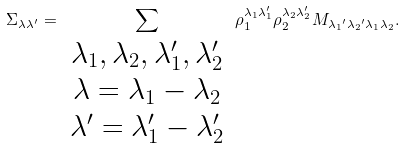<formula> <loc_0><loc_0><loc_500><loc_500>\Sigma _ { \lambda \lambda ^ { \prime } } = \sum _ { \begin{array} { c } \lambda _ { 1 } , \lambda _ { 2 } , \lambda _ { 1 } ^ { \prime } , \lambda _ { 2 } ^ { \prime } \\ \lambda = \lambda _ { 1 } - \lambda _ { 2 } \\ \lambda ^ { \prime } = \lambda _ { 1 } ^ { \prime } - \lambda _ { 2 } ^ { \prime } \end{array} } \rho _ { 1 } ^ { \lambda _ { 1 } \lambda _ { 1 } ^ { \prime } } \rho _ { 2 } ^ { \lambda _ { 2 } \lambda _ { 2 } ^ { \prime } } M _ { { \lambda _ { 1 } } ^ { \prime } { \lambda _ { 2 } } ^ { \prime } \lambda _ { 1 } \lambda _ { 2 } } .</formula> 